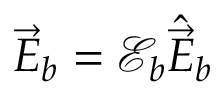Convert formula to latex. <formula><loc_0><loc_0><loc_500><loc_500>\vec { E } _ { b } = \mathcal { E } _ { b } \hat { \vec { E } } _ { b }</formula> 